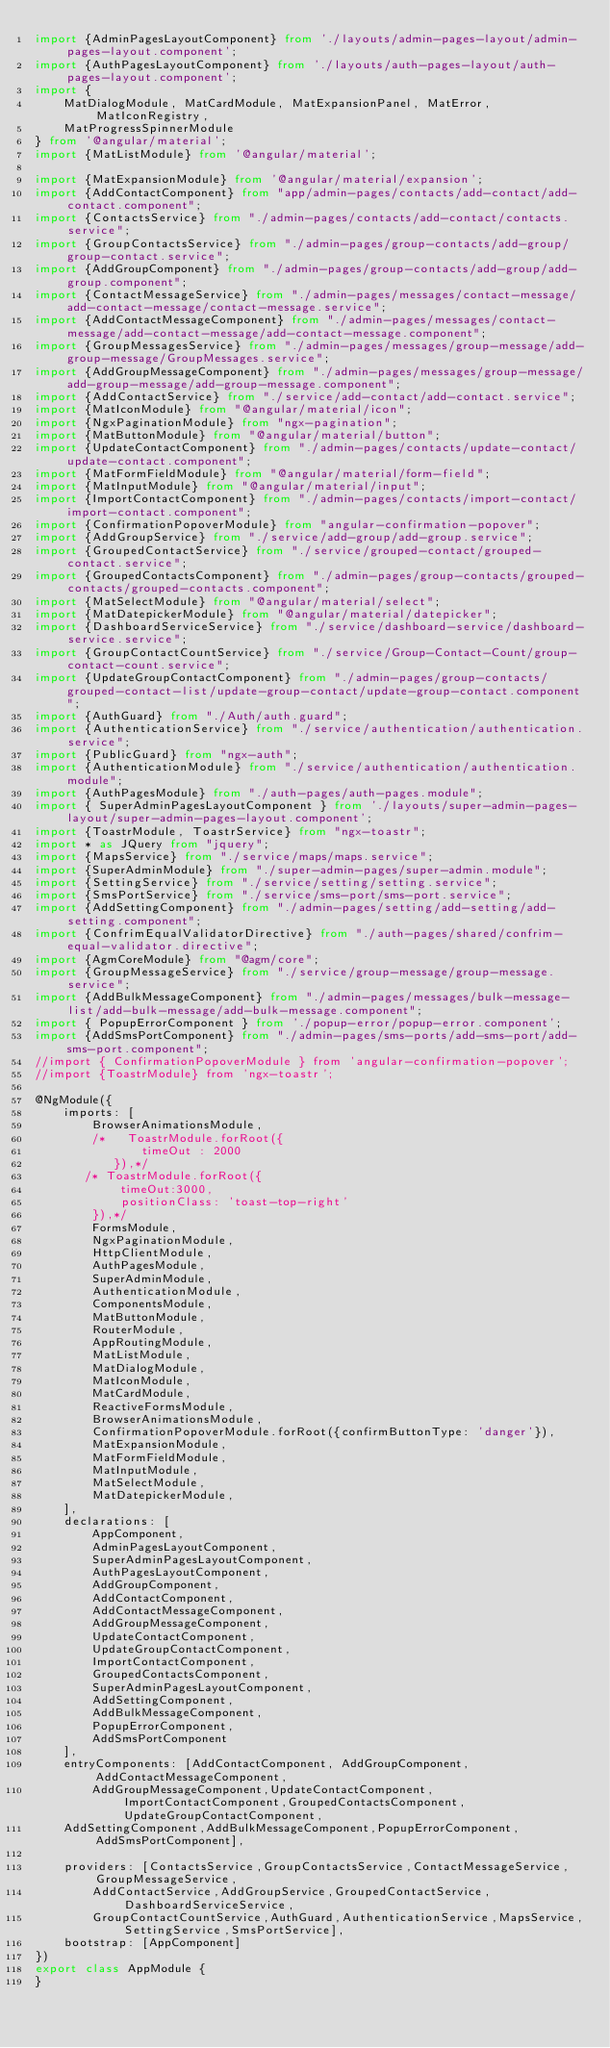Convert code to text. <code><loc_0><loc_0><loc_500><loc_500><_TypeScript_>import {AdminPagesLayoutComponent} from './layouts/admin-pages-layout/admin-pages-layout.component';
import {AuthPagesLayoutComponent} from './layouts/auth-pages-layout/auth-pages-layout.component';
import {
    MatDialogModule, MatCardModule, MatExpansionPanel, MatError, MatIconRegistry,
    MatProgressSpinnerModule
} from '@angular/material';
import {MatListModule} from '@angular/material';

import {MatExpansionModule} from '@angular/material/expansion';
import {AddContactComponent} from "app/admin-pages/contacts/add-contact/add-contact.component";
import {ContactsService} from "./admin-pages/contacts/add-contact/contacts.service";
import {GroupContactsService} from "./admin-pages/group-contacts/add-group/group-contact.service";
import {AddGroupComponent} from "./admin-pages/group-contacts/add-group/add-group.component";
import {ContactMessageService} from "./admin-pages/messages/contact-message/add-contact-message/contact-message.service";
import {AddContactMessageComponent} from "./admin-pages/messages/contact-message/add-contact-message/add-contact-message.component";
import {GroupMessagesService} from "./admin-pages/messages/group-message/add-group-message/GroupMessages.service";
import {AddGroupMessageComponent} from "./admin-pages/messages/group-message/add-group-message/add-group-message.component";
import {AddContactService} from "./service/add-contact/add-contact.service";
import {MatIconModule} from "@angular/material/icon";
import {NgxPaginationModule} from "ngx-pagination";
import {MatButtonModule} from "@angular/material/button";
import {UpdateContactComponent} from "./admin-pages/contacts/update-contact/update-contact.component";
import {MatFormFieldModule} from "@angular/material/form-field";
import {MatInputModule} from "@angular/material/input";
import {ImportContactComponent} from "./admin-pages/contacts/import-contact/import-contact.component";
import {ConfirmationPopoverModule} from "angular-confirmation-popover";
import {AddGroupService} from "./service/add-group/add-group.service";
import {GroupedContactService} from "./service/grouped-contact/grouped-contact.service";
import {GroupedContactsComponent} from "./admin-pages/group-contacts/grouped-contacts/grouped-contacts.component";
import {MatSelectModule} from "@angular/material/select";
import {MatDatepickerModule} from "@angular/material/datepicker";
import {DashboardServiceService} from "./service/dashboard-service/dashboard-service.service";
import {GroupContactCountService} from "./service/Group-Contact-Count/group-contact-count.service";
import {UpdateGroupContactComponent} from "./admin-pages/group-contacts/grouped-contact-list/update-group-contact/update-group-contact.component";
import {AuthGuard} from "./Auth/auth.guard";
import {AuthenticationService} from "./service/authentication/authentication.service";
import {PublicGuard} from "ngx-auth";
import {AuthenticationModule} from "./service/authentication/authentication.module";
import {AuthPagesModule} from "./auth-pages/auth-pages.module";
import { SuperAdminPagesLayoutComponent } from './layouts/super-admin-pages-layout/super-admin-pages-layout.component';
import {ToastrModule, ToastrService} from "ngx-toastr";
import * as JQuery from "jquery";
import {MapsService} from "./service/maps/maps.service";
import {SuperAdminModule} from "./super-admin-pages/super-admin.module";
import {SettingService} from "./service/setting/setting.service";
import {SmsPortService} from "./service/sms-port/sms-port.service";
import {AddSettingComponent} from "./admin-pages/setting/add-setting/add-setting.component";
import {ConfrimEqualValidatorDirective} from "./auth-pages/shared/confrim-equal-validator.directive";
import {AgmCoreModule} from "@agm/core";
import {GroupMessageService} from "./service/group-message/group-message.service";
import {AddBulkMessageComponent} from "./admin-pages/messages/bulk-message-list/add-bulk-message/add-bulk-message.component";
import { PopupErrorComponent } from './popup-error/popup-error.component';
import {AddSmsPortComponent} from "./admin-pages/sms-ports/add-sms-port/add-sms-port.component";
//import { ConfirmationPopoverModule } from 'angular-confirmation-popover';
//import {ToastrModule} from 'ngx-toastr';

@NgModule({
    imports: [
        BrowserAnimationsModule,
        /*   ToastrModule.forRoot({
               timeOut : 2000
           }),*/
       /* ToastrModule.forRoot({
            timeOut:3000,
            positionClass: 'toast-top-right'
        }),*/
        FormsModule,
        NgxPaginationModule,
        HttpClientModule,
        AuthPagesModule,
        SuperAdminModule,
        AuthenticationModule,
        ComponentsModule,
        MatButtonModule,
        RouterModule,
        AppRoutingModule,
        MatListModule,
        MatDialogModule,
        MatIconModule,
        MatCardModule,
        ReactiveFormsModule,
        BrowserAnimationsModule,
        ConfirmationPopoverModule.forRoot({confirmButtonType: 'danger'}),
        MatExpansionModule,
        MatFormFieldModule,
        MatInputModule,
        MatSelectModule,
        MatDatepickerModule,
    ],
    declarations: [
        AppComponent,
        AdminPagesLayoutComponent,
        SuperAdminPagesLayoutComponent,
        AuthPagesLayoutComponent,
        AddGroupComponent,
        AddContactComponent,
        AddContactMessageComponent,
        AddGroupMessageComponent,
        UpdateContactComponent,
        UpdateGroupContactComponent,
        ImportContactComponent,
        GroupedContactsComponent,
        SuperAdminPagesLayoutComponent,
        AddSettingComponent,
        AddBulkMessageComponent,
        PopupErrorComponent,
        AddSmsPortComponent
    ],
    entryComponents: [AddContactComponent, AddGroupComponent,AddContactMessageComponent,
        AddGroupMessageComponent,UpdateContactComponent,ImportContactComponent,GroupedContactsComponent,UpdateGroupContactComponent,
    AddSettingComponent,AddBulkMessageComponent,PopupErrorComponent,AddSmsPortComponent],

    providers: [ContactsService,GroupContactsService,ContactMessageService,GroupMessageService,
        AddContactService,AddGroupService,GroupedContactService,DashboardServiceService,
        GroupContactCountService,AuthGuard,AuthenticationService,MapsService,SettingService,SmsPortService],
    bootstrap: [AppComponent]
})
export class AppModule {
}
</code> 